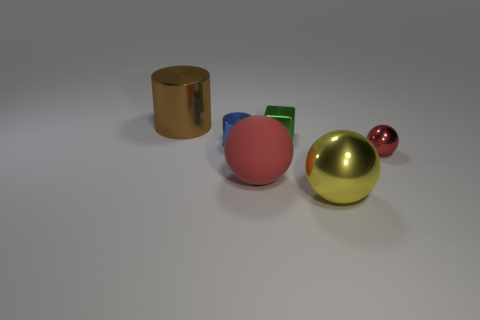There is a sphere that is the same color as the rubber object; what is its size?
Make the answer very short. Small. How many other things are there of the same size as the brown shiny object?
Offer a terse response. 2. There is a large shiny object that is behind the red object on the left side of the tiny red object; is there a small green object behind it?
Your answer should be compact. No. Is there any other thing that has the same color as the small metal block?
Give a very brief answer. No. There is a metal ball behind the large matte ball; what size is it?
Ensure brevity in your answer.  Small. There is a red object in front of the red thing to the right of the big metallic object that is to the right of the brown thing; what size is it?
Keep it short and to the point. Large. The large object that is behind the metal sphere right of the big yellow metal ball is what color?
Your answer should be compact. Brown. What is the material of the other small object that is the same shape as the yellow thing?
Offer a very short reply. Metal. Is there any other thing that is made of the same material as the green thing?
Give a very brief answer. Yes. There is a large red ball; are there any metal spheres in front of it?
Provide a succinct answer. Yes. 